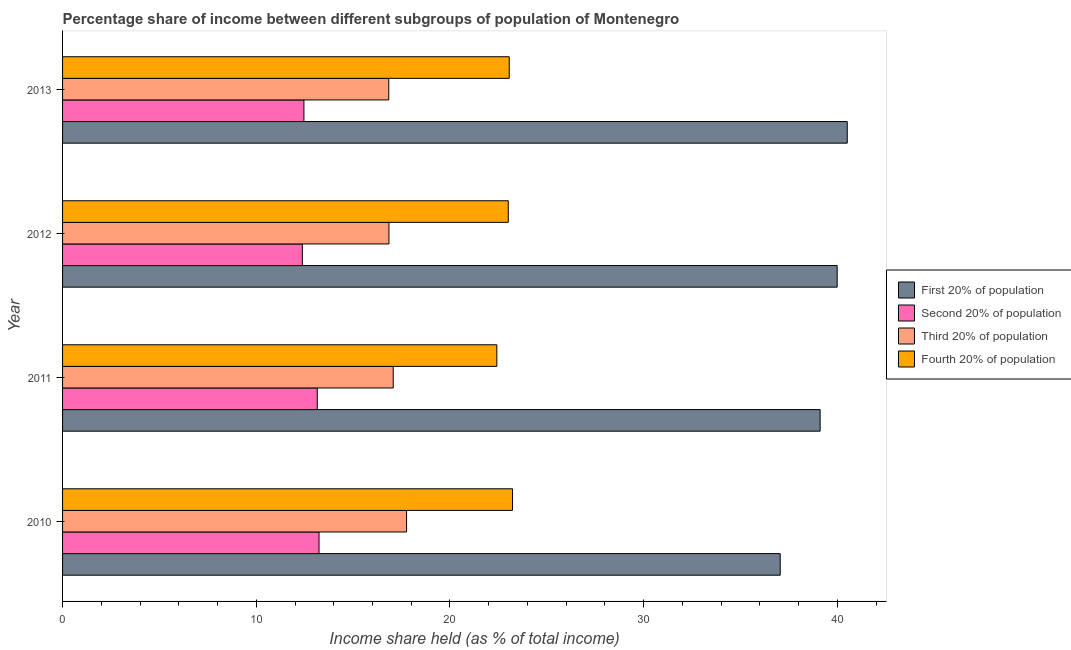How many different coloured bars are there?
Keep it short and to the point. 4. Are the number of bars per tick equal to the number of legend labels?
Your answer should be compact. Yes. How many bars are there on the 3rd tick from the bottom?
Make the answer very short. 4. What is the share of the income held by third 20% of the population in 2013?
Make the answer very short. 16.84. Across all years, what is the maximum share of the income held by third 20% of the population?
Keep it short and to the point. 17.76. Across all years, what is the minimum share of the income held by first 20% of the population?
Your response must be concise. 37.05. In which year was the share of the income held by second 20% of the population maximum?
Offer a very short reply. 2010. What is the total share of the income held by fourth 20% of the population in the graph?
Your answer should be compact. 91.72. What is the difference between the share of the income held by first 20% of the population in 2011 and that in 2012?
Provide a succinct answer. -0.88. What is the difference between the share of the income held by second 20% of the population in 2010 and the share of the income held by third 20% of the population in 2013?
Make the answer very short. -3.6. What is the average share of the income held by second 20% of the population per year?
Your answer should be compact. 12.81. In the year 2012, what is the difference between the share of the income held by fourth 20% of the population and share of the income held by first 20% of the population?
Make the answer very short. -16.98. What is the ratio of the share of the income held by second 20% of the population in 2010 to that in 2011?
Your answer should be very brief. 1.01. What is the difference between the highest and the second highest share of the income held by third 20% of the population?
Your answer should be compact. 0.69. What is the difference between the highest and the lowest share of the income held by first 20% of the population?
Make the answer very short. 3.46. Is it the case that in every year, the sum of the share of the income held by fourth 20% of the population and share of the income held by third 20% of the population is greater than the sum of share of the income held by first 20% of the population and share of the income held by second 20% of the population?
Make the answer very short. No. What does the 1st bar from the top in 2010 represents?
Provide a short and direct response. Fourth 20% of population. What does the 1st bar from the bottom in 2011 represents?
Your answer should be very brief. First 20% of population. Is it the case that in every year, the sum of the share of the income held by first 20% of the population and share of the income held by second 20% of the population is greater than the share of the income held by third 20% of the population?
Give a very brief answer. Yes. How many bars are there?
Give a very brief answer. 16. Are all the bars in the graph horizontal?
Give a very brief answer. Yes. What is the difference between two consecutive major ticks on the X-axis?
Provide a short and direct response. 10. Are the values on the major ticks of X-axis written in scientific E-notation?
Your response must be concise. No. Does the graph contain any zero values?
Provide a short and direct response. No. What is the title of the graph?
Provide a succinct answer. Percentage share of income between different subgroups of population of Montenegro. Does "Tertiary schools" appear as one of the legend labels in the graph?
Keep it short and to the point. No. What is the label or title of the X-axis?
Ensure brevity in your answer.  Income share held (as % of total income). What is the label or title of the Y-axis?
Keep it short and to the point. Year. What is the Income share held (as % of total income) of First 20% of population in 2010?
Give a very brief answer. 37.05. What is the Income share held (as % of total income) of Second 20% of population in 2010?
Your response must be concise. 13.24. What is the Income share held (as % of total income) of Third 20% of population in 2010?
Offer a very short reply. 17.76. What is the Income share held (as % of total income) of Fourth 20% of population in 2010?
Provide a succinct answer. 23.23. What is the Income share held (as % of total income) of First 20% of population in 2011?
Your answer should be very brief. 39.11. What is the Income share held (as % of total income) of Second 20% of population in 2011?
Provide a succinct answer. 13.15. What is the Income share held (as % of total income) of Third 20% of population in 2011?
Offer a very short reply. 17.07. What is the Income share held (as % of total income) in Fourth 20% of population in 2011?
Keep it short and to the point. 22.42. What is the Income share held (as % of total income) in First 20% of population in 2012?
Offer a very short reply. 39.99. What is the Income share held (as % of total income) in Second 20% of population in 2012?
Your answer should be very brief. 12.38. What is the Income share held (as % of total income) in Third 20% of population in 2012?
Your response must be concise. 16.85. What is the Income share held (as % of total income) of Fourth 20% of population in 2012?
Keep it short and to the point. 23.01. What is the Income share held (as % of total income) of First 20% of population in 2013?
Give a very brief answer. 40.51. What is the Income share held (as % of total income) of Second 20% of population in 2013?
Make the answer very short. 12.46. What is the Income share held (as % of total income) in Third 20% of population in 2013?
Your response must be concise. 16.84. What is the Income share held (as % of total income) of Fourth 20% of population in 2013?
Offer a terse response. 23.06. Across all years, what is the maximum Income share held (as % of total income) of First 20% of population?
Offer a very short reply. 40.51. Across all years, what is the maximum Income share held (as % of total income) in Second 20% of population?
Your answer should be compact. 13.24. Across all years, what is the maximum Income share held (as % of total income) of Third 20% of population?
Your response must be concise. 17.76. Across all years, what is the maximum Income share held (as % of total income) of Fourth 20% of population?
Offer a very short reply. 23.23. Across all years, what is the minimum Income share held (as % of total income) in First 20% of population?
Your response must be concise. 37.05. Across all years, what is the minimum Income share held (as % of total income) in Second 20% of population?
Provide a succinct answer. 12.38. Across all years, what is the minimum Income share held (as % of total income) of Third 20% of population?
Keep it short and to the point. 16.84. Across all years, what is the minimum Income share held (as % of total income) of Fourth 20% of population?
Ensure brevity in your answer.  22.42. What is the total Income share held (as % of total income) in First 20% of population in the graph?
Provide a short and direct response. 156.66. What is the total Income share held (as % of total income) of Second 20% of population in the graph?
Your answer should be compact. 51.23. What is the total Income share held (as % of total income) in Third 20% of population in the graph?
Provide a short and direct response. 68.52. What is the total Income share held (as % of total income) in Fourth 20% of population in the graph?
Give a very brief answer. 91.72. What is the difference between the Income share held (as % of total income) of First 20% of population in 2010 and that in 2011?
Ensure brevity in your answer.  -2.06. What is the difference between the Income share held (as % of total income) in Second 20% of population in 2010 and that in 2011?
Give a very brief answer. 0.09. What is the difference between the Income share held (as % of total income) of Third 20% of population in 2010 and that in 2011?
Keep it short and to the point. 0.69. What is the difference between the Income share held (as % of total income) in Fourth 20% of population in 2010 and that in 2011?
Offer a very short reply. 0.81. What is the difference between the Income share held (as % of total income) of First 20% of population in 2010 and that in 2012?
Keep it short and to the point. -2.94. What is the difference between the Income share held (as % of total income) in Second 20% of population in 2010 and that in 2012?
Provide a short and direct response. 0.86. What is the difference between the Income share held (as % of total income) of Third 20% of population in 2010 and that in 2012?
Keep it short and to the point. 0.91. What is the difference between the Income share held (as % of total income) of Fourth 20% of population in 2010 and that in 2012?
Offer a very short reply. 0.22. What is the difference between the Income share held (as % of total income) in First 20% of population in 2010 and that in 2013?
Make the answer very short. -3.46. What is the difference between the Income share held (as % of total income) in Second 20% of population in 2010 and that in 2013?
Your answer should be very brief. 0.78. What is the difference between the Income share held (as % of total income) in Fourth 20% of population in 2010 and that in 2013?
Provide a succinct answer. 0.17. What is the difference between the Income share held (as % of total income) in First 20% of population in 2011 and that in 2012?
Ensure brevity in your answer.  -0.88. What is the difference between the Income share held (as % of total income) of Second 20% of population in 2011 and that in 2012?
Provide a succinct answer. 0.77. What is the difference between the Income share held (as % of total income) in Third 20% of population in 2011 and that in 2012?
Provide a short and direct response. 0.22. What is the difference between the Income share held (as % of total income) of Fourth 20% of population in 2011 and that in 2012?
Provide a short and direct response. -0.59. What is the difference between the Income share held (as % of total income) in Second 20% of population in 2011 and that in 2013?
Make the answer very short. 0.69. What is the difference between the Income share held (as % of total income) of Third 20% of population in 2011 and that in 2013?
Offer a terse response. 0.23. What is the difference between the Income share held (as % of total income) in Fourth 20% of population in 2011 and that in 2013?
Provide a succinct answer. -0.64. What is the difference between the Income share held (as % of total income) of First 20% of population in 2012 and that in 2013?
Provide a succinct answer. -0.52. What is the difference between the Income share held (as % of total income) in Second 20% of population in 2012 and that in 2013?
Keep it short and to the point. -0.08. What is the difference between the Income share held (as % of total income) in Third 20% of population in 2012 and that in 2013?
Offer a terse response. 0.01. What is the difference between the Income share held (as % of total income) in Fourth 20% of population in 2012 and that in 2013?
Your answer should be compact. -0.05. What is the difference between the Income share held (as % of total income) in First 20% of population in 2010 and the Income share held (as % of total income) in Second 20% of population in 2011?
Offer a very short reply. 23.9. What is the difference between the Income share held (as % of total income) in First 20% of population in 2010 and the Income share held (as % of total income) in Third 20% of population in 2011?
Provide a short and direct response. 19.98. What is the difference between the Income share held (as % of total income) in First 20% of population in 2010 and the Income share held (as % of total income) in Fourth 20% of population in 2011?
Give a very brief answer. 14.63. What is the difference between the Income share held (as % of total income) in Second 20% of population in 2010 and the Income share held (as % of total income) in Third 20% of population in 2011?
Your answer should be very brief. -3.83. What is the difference between the Income share held (as % of total income) of Second 20% of population in 2010 and the Income share held (as % of total income) of Fourth 20% of population in 2011?
Make the answer very short. -9.18. What is the difference between the Income share held (as % of total income) in Third 20% of population in 2010 and the Income share held (as % of total income) in Fourth 20% of population in 2011?
Offer a very short reply. -4.66. What is the difference between the Income share held (as % of total income) in First 20% of population in 2010 and the Income share held (as % of total income) in Second 20% of population in 2012?
Your response must be concise. 24.67. What is the difference between the Income share held (as % of total income) of First 20% of population in 2010 and the Income share held (as % of total income) of Third 20% of population in 2012?
Give a very brief answer. 20.2. What is the difference between the Income share held (as % of total income) in First 20% of population in 2010 and the Income share held (as % of total income) in Fourth 20% of population in 2012?
Provide a succinct answer. 14.04. What is the difference between the Income share held (as % of total income) of Second 20% of population in 2010 and the Income share held (as % of total income) of Third 20% of population in 2012?
Make the answer very short. -3.61. What is the difference between the Income share held (as % of total income) in Second 20% of population in 2010 and the Income share held (as % of total income) in Fourth 20% of population in 2012?
Your answer should be very brief. -9.77. What is the difference between the Income share held (as % of total income) of Third 20% of population in 2010 and the Income share held (as % of total income) of Fourth 20% of population in 2012?
Ensure brevity in your answer.  -5.25. What is the difference between the Income share held (as % of total income) of First 20% of population in 2010 and the Income share held (as % of total income) of Second 20% of population in 2013?
Your answer should be very brief. 24.59. What is the difference between the Income share held (as % of total income) in First 20% of population in 2010 and the Income share held (as % of total income) in Third 20% of population in 2013?
Your response must be concise. 20.21. What is the difference between the Income share held (as % of total income) in First 20% of population in 2010 and the Income share held (as % of total income) in Fourth 20% of population in 2013?
Offer a very short reply. 13.99. What is the difference between the Income share held (as % of total income) of Second 20% of population in 2010 and the Income share held (as % of total income) of Fourth 20% of population in 2013?
Offer a very short reply. -9.82. What is the difference between the Income share held (as % of total income) in First 20% of population in 2011 and the Income share held (as % of total income) in Second 20% of population in 2012?
Make the answer very short. 26.73. What is the difference between the Income share held (as % of total income) in First 20% of population in 2011 and the Income share held (as % of total income) in Third 20% of population in 2012?
Provide a succinct answer. 22.26. What is the difference between the Income share held (as % of total income) of First 20% of population in 2011 and the Income share held (as % of total income) of Fourth 20% of population in 2012?
Offer a terse response. 16.1. What is the difference between the Income share held (as % of total income) in Second 20% of population in 2011 and the Income share held (as % of total income) in Third 20% of population in 2012?
Offer a terse response. -3.7. What is the difference between the Income share held (as % of total income) in Second 20% of population in 2011 and the Income share held (as % of total income) in Fourth 20% of population in 2012?
Give a very brief answer. -9.86. What is the difference between the Income share held (as % of total income) in Third 20% of population in 2011 and the Income share held (as % of total income) in Fourth 20% of population in 2012?
Your answer should be compact. -5.94. What is the difference between the Income share held (as % of total income) of First 20% of population in 2011 and the Income share held (as % of total income) of Second 20% of population in 2013?
Keep it short and to the point. 26.65. What is the difference between the Income share held (as % of total income) in First 20% of population in 2011 and the Income share held (as % of total income) in Third 20% of population in 2013?
Your answer should be very brief. 22.27. What is the difference between the Income share held (as % of total income) in First 20% of population in 2011 and the Income share held (as % of total income) in Fourth 20% of population in 2013?
Keep it short and to the point. 16.05. What is the difference between the Income share held (as % of total income) of Second 20% of population in 2011 and the Income share held (as % of total income) of Third 20% of population in 2013?
Provide a short and direct response. -3.69. What is the difference between the Income share held (as % of total income) in Second 20% of population in 2011 and the Income share held (as % of total income) in Fourth 20% of population in 2013?
Provide a succinct answer. -9.91. What is the difference between the Income share held (as % of total income) of Third 20% of population in 2011 and the Income share held (as % of total income) of Fourth 20% of population in 2013?
Offer a very short reply. -5.99. What is the difference between the Income share held (as % of total income) in First 20% of population in 2012 and the Income share held (as % of total income) in Second 20% of population in 2013?
Provide a succinct answer. 27.53. What is the difference between the Income share held (as % of total income) in First 20% of population in 2012 and the Income share held (as % of total income) in Third 20% of population in 2013?
Give a very brief answer. 23.15. What is the difference between the Income share held (as % of total income) in First 20% of population in 2012 and the Income share held (as % of total income) in Fourth 20% of population in 2013?
Make the answer very short. 16.93. What is the difference between the Income share held (as % of total income) of Second 20% of population in 2012 and the Income share held (as % of total income) of Third 20% of population in 2013?
Ensure brevity in your answer.  -4.46. What is the difference between the Income share held (as % of total income) of Second 20% of population in 2012 and the Income share held (as % of total income) of Fourth 20% of population in 2013?
Keep it short and to the point. -10.68. What is the difference between the Income share held (as % of total income) of Third 20% of population in 2012 and the Income share held (as % of total income) of Fourth 20% of population in 2013?
Give a very brief answer. -6.21. What is the average Income share held (as % of total income) of First 20% of population per year?
Provide a succinct answer. 39.16. What is the average Income share held (as % of total income) in Second 20% of population per year?
Provide a short and direct response. 12.81. What is the average Income share held (as % of total income) in Third 20% of population per year?
Your answer should be compact. 17.13. What is the average Income share held (as % of total income) of Fourth 20% of population per year?
Provide a succinct answer. 22.93. In the year 2010, what is the difference between the Income share held (as % of total income) of First 20% of population and Income share held (as % of total income) of Second 20% of population?
Keep it short and to the point. 23.81. In the year 2010, what is the difference between the Income share held (as % of total income) in First 20% of population and Income share held (as % of total income) in Third 20% of population?
Provide a succinct answer. 19.29. In the year 2010, what is the difference between the Income share held (as % of total income) of First 20% of population and Income share held (as % of total income) of Fourth 20% of population?
Your response must be concise. 13.82. In the year 2010, what is the difference between the Income share held (as % of total income) of Second 20% of population and Income share held (as % of total income) of Third 20% of population?
Offer a terse response. -4.52. In the year 2010, what is the difference between the Income share held (as % of total income) of Second 20% of population and Income share held (as % of total income) of Fourth 20% of population?
Your answer should be very brief. -9.99. In the year 2010, what is the difference between the Income share held (as % of total income) of Third 20% of population and Income share held (as % of total income) of Fourth 20% of population?
Your response must be concise. -5.47. In the year 2011, what is the difference between the Income share held (as % of total income) in First 20% of population and Income share held (as % of total income) in Second 20% of population?
Keep it short and to the point. 25.96. In the year 2011, what is the difference between the Income share held (as % of total income) of First 20% of population and Income share held (as % of total income) of Third 20% of population?
Your answer should be very brief. 22.04. In the year 2011, what is the difference between the Income share held (as % of total income) in First 20% of population and Income share held (as % of total income) in Fourth 20% of population?
Provide a succinct answer. 16.69. In the year 2011, what is the difference between the Income share held (as % of total income) in Second 20% of population and Income share held (as % of total income) in Third 20% of population?
Your response must be concise. -3.92. In the year 2011, what is the difference between the Income share held (as % of total income) in Second 20% of population and Income share held (as % of total income) in Fourth 20% of population?
Make the answer very short. -9.27. In the year 2011, what is the difference between the Income share held (as % of total income) in Third 20% of population and Income share held (as % of total income) in Fourth 20% of population?
Give a very brief answer. -5.35. In the year 2012, what is the difference between the Income share held (as % of total income) in First 20% of population and Income share held (as % of total income) in Second 20% of population?
Your answer should be compact. 27.61. In the year 2012, what is the difference between the Income share held (as % of total income) of First 20% of population and Income share held (as % of total income) of Third 20% of population?
Offer a very short reply. 23.14. In the year 2012, what is the difference between the Income share held (as % of total income) of First 20% of population and Income share held (as % of total income) of Fourth 20% of population?
Provide a short and direct response. 16.98. In the year 2012, what is the difference between the Income share held (as % of total income) of Second 20% of population and Income share held (as % of total income) of Third 20% of population?
Keep it short and to the point. -4.47. In the year 2012, what is the difference between the Income share held (as % of total income) of Second 20% of population and Income share held (as % of total income) of Fourth 20% of population?
Your response must be concise. -10.63. In the year 2012, what is the difference between the Income share held (as % of total income) in Third 20% of population and Income share held (as % of total income) in Fourth 20% of population?
Your answer should be very brief. -6.16. In the year 2013, what is the difference between the Income share held (as % of total income) in First 20% of population and Income share held (as % of total income) in Second 20% of population?
Ensure brevity in your answer.  28.05. In the year 2013, what is the difference between the Income share held (as % of total income) of First 20% of population and Income share held (as % of total income) of Third 20% of population?
Your answer should be compact. 23.67. In the year 2013, what is the difference between the Income share held (as % of total income) in First 20% of population and Income share held (as % of total income) in Fourth 20% of population?
Your answer should be compact. 17.45. In the year 2013, what is the difference between the Income share held (as % of total income) of Second 20% of population and Income share held (as % of total income) of Third 20% of population?
Keep it short and to the point. -4.38. In the year 2013, what is the difference between the Income share held (as % of total income) in Second 20% of population and Income share held (as % of total income) in Fourth 20% of population?
Your response must be concise. -10.6. In the year 2013, what is the difference between the Income share held (as % of total income) of Third 20% of population and Income share held (as % of total income) of Fourth 20% of population?
Your response must be concise. -6.22. What is the ratio of the Income share held (as % of total income) in First 20% of population in 2010 to that in 2011?
Your answer should be compact. 0.95. What is the ratio of the Income share held (as % of total income) in Second 20% of population in 2010 to that in 2011?
Give a very brief answer. 1.01. What is the ratio of the Income share held (as % of total income) of Third 20% of population in 2010 to that in 2011?
Give a very brief answer. 1.04. What is the ratio of the Income share held (as % of total income) in Fourth 20% of population in 2010 to that in 2011?
Give a very brief answer. 1.04. What is the ratio of the Income share held (as % of total income) of First 20% of population in 2010 to that in 2012?
Offer a terse response. 0.93. What is the ratio of the Income share held (as % of total income) in Second 20% of population in 2010 to that in 2012?
Give a very brief answer. 1.07. What is the ratio of the Income share held (as % of total income) in Third 20% of population in 2010 to that in 2012?
Your response must be concise. 1.05. What is the ratio of the Income share held (as % of total income) in Fourth 20% of population in 2010 to that in 2012?
Make the answer very short. 1.01. What is the ratio of the Income share held (as % of total income) in First 20% of population in 2010 to that in 2013?
Give a very brief answer. 0.91. What is the ratio of the Income share held (as % of total income) of Second 20% of population in 2010 to that in 2013?
Give a very brief answer. 1.06. What is the ratio of the Income share held (as % of total income) in Third 20% of population in 2010 to that in 2013?
Your response must be concise. 1.05. What is the ratio of the Income share held (as % of total income) in Fourth 20% of population in 2010 to that in 2013?
Offer a terse response. 1.01. What is the ratio of the Income share held (as % of total income) of Second 20% of population in 2011 to that in 2012?
Give a very brief answer. 1.06. What is the ratio of the Income share held (as % of total income) in Third 20% of population in 2011 to that in 2012?
Your answer should be compact. 1.01. What is the ratio of the Income share held (as % of total income) of Fourth 20% of population in 2011 to that in 2012?
Provide a short and direct response. 0.97. What is the ratio of the Income share held (as % of total income) of First 20% of population in 2011 to that in 2013?
Make the answer very short. 0.97. What is the ratio of the Income share held (as % of total income) of Second 20% of population in 2011 to that in 2013?
Provide a succinct answer. 1.06. What is the ratio of the Income share held (as % of total income) in Third 20% of population in 2011 to that in 2013?
Give a very brief answer. 1.01. What is the ratio of the Income share held (as % of total income) in Fourth 20% of population in 2011 to that in 2013?
Provide a succinct answer. 0.97. What is the ratio of the Income share held (as % of total income) in First 20% of population in 2012 to that in 2013?
Your answer should be very brief. 0.99. What is the ratio of the Income share held (as % of total income) in Second 20% of population in 2012 to that in 2013?
Ensure brevity in your answer.  0.99. What is the ratio of the Income share held (as % of total income) in Third 20% of population in 2012 to that in 2013?
Your answer should be compact. 1. What is the difference between the highest and the second highest Income share held (as % of total income) of First 20% of population?
Your answer should be compact. 0.52. What is the difference between the highest and the second highest Income share held (as % of total income) in Second 20% of population?
Offer a terse response. 0.09. What is the difference between the highest and the second highest Income share held (as % of total income) of Third 20% of population?
Your answer should be very brief. 0.69. What is the difference between the highest and the second highest Income share held (as % of total income) of Fourth 20% of population?
Your answer should be very brief. 0.17. What is the difference between the highest and the lowest Income share held (as % of total income) in First 20% of population?
Keep it short and to the point. 3.46. What is the difference between the highest and the lowest Income share held (as % of total income) in Second 20% of population?
Keep it short and to the point. 0.86. What is the difference between the highest and the lowest Income share held (as % of total income) of Third 20% of population?
Offer a terse response. 0.92. What is the difference between the highest and the lowest Income share held (as % of total income) in Fourth 20% of population?
Make the answer very short. 0.81. 